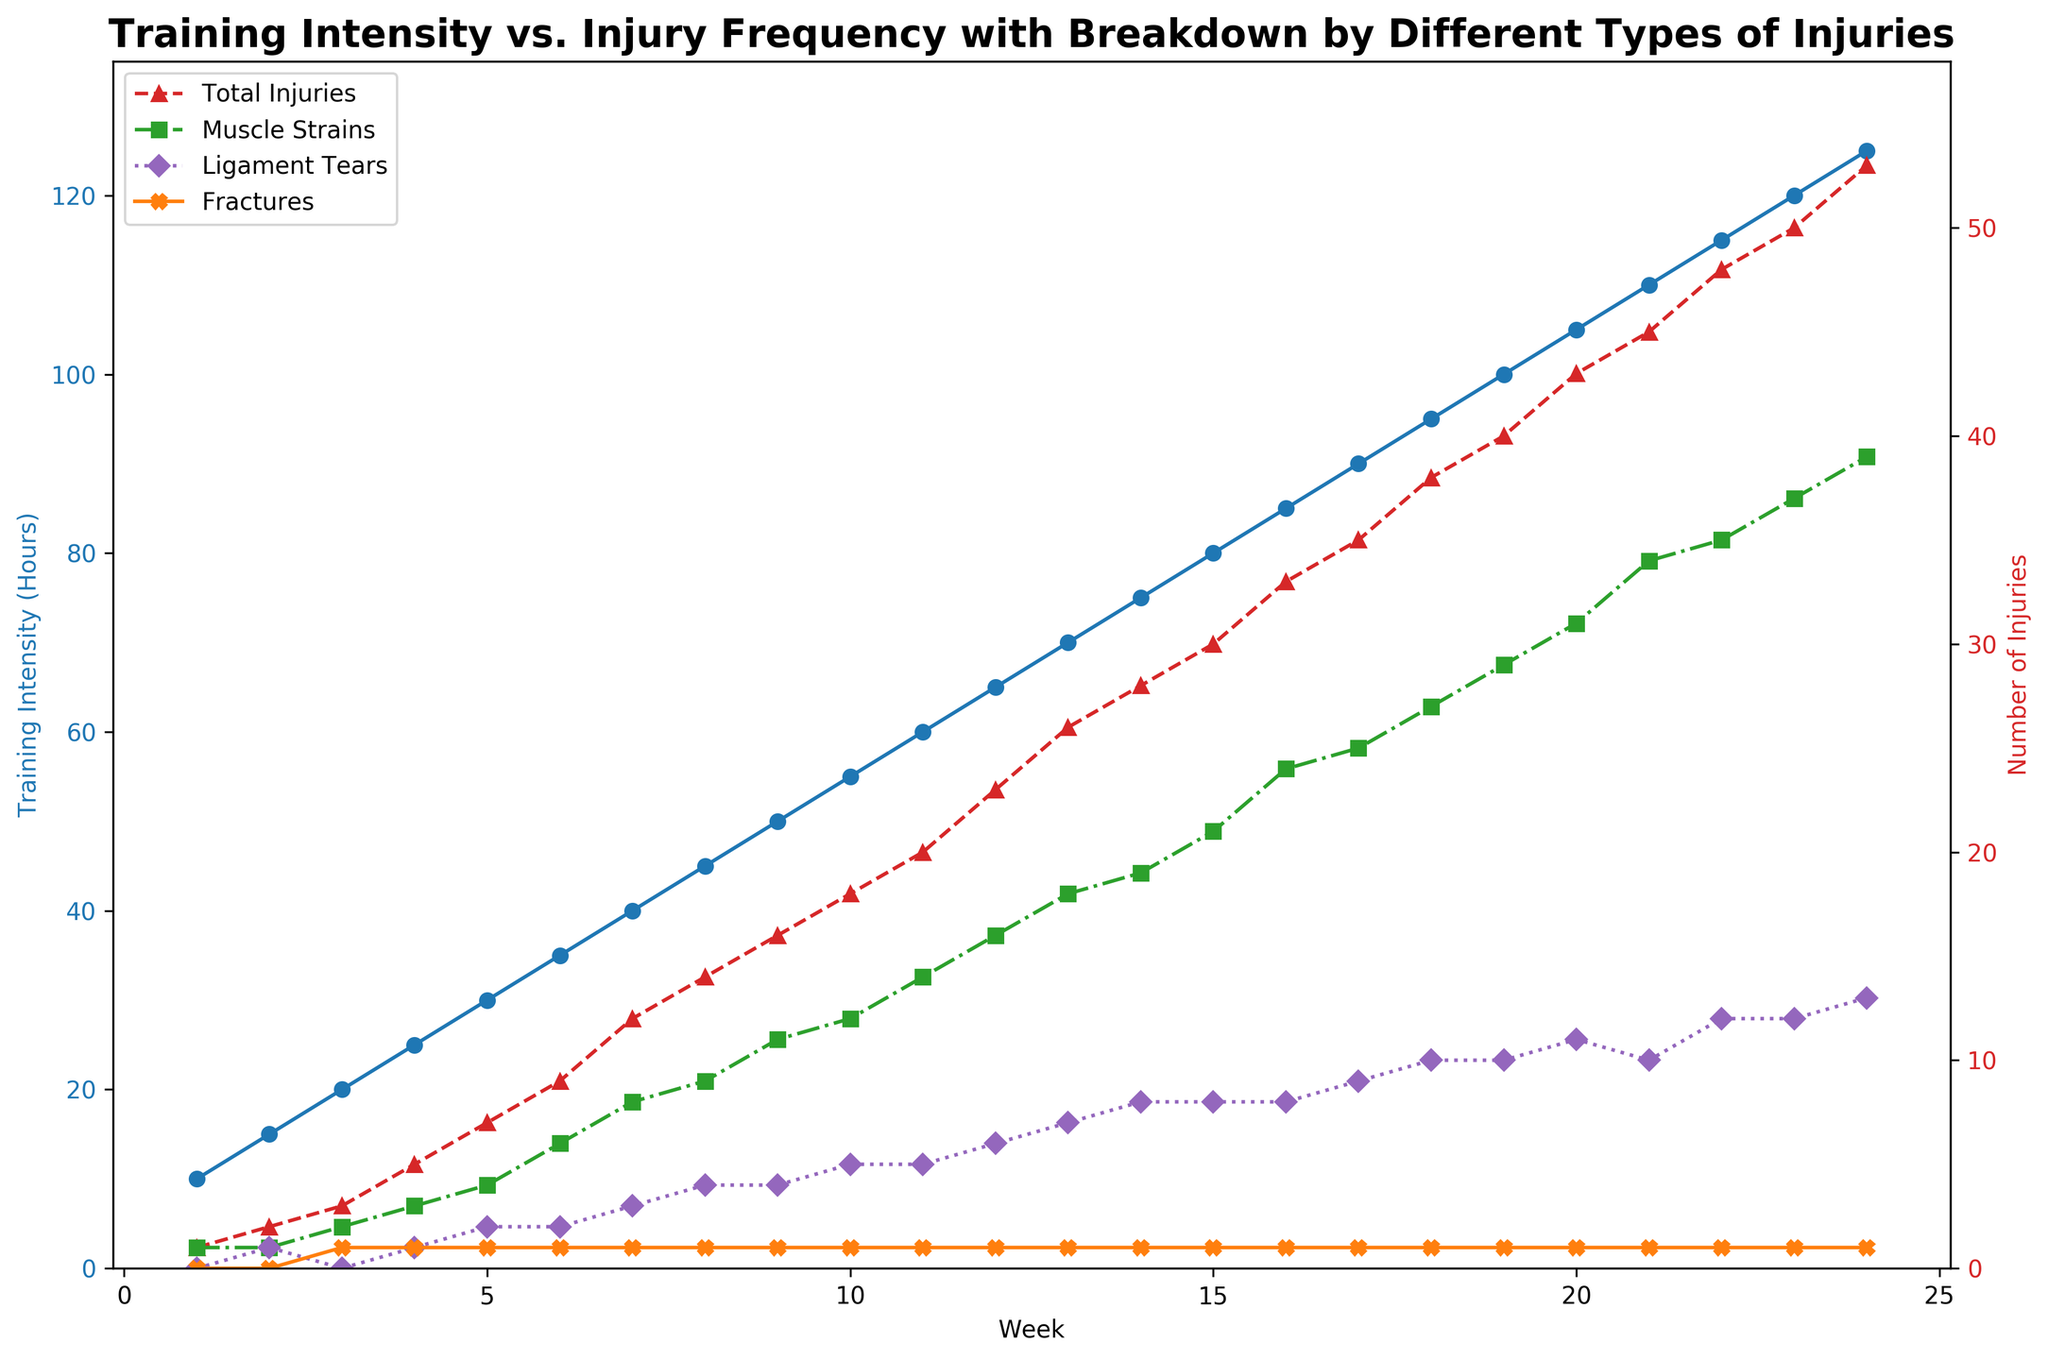How does the training intensity change from week 1 to week 24? To determine the change, compare the values at week 1 and week 24. At week 1, the training intensity is 10 hours. At week 24, it is 125 hours. The change is 125 - 10 = 115 hours.
Answer: 115 hours Which week has the highest number of muscle strains? Look for the maximum value in the muscle strains line plot and map it to the week. The maximum number of muscle strains is 39, which occurs in week 24.
Answer: Week 24 What is the general trend of total injuries as training intensity increases? Generally, observe the pattern in both total injuries and training intensity lines. As the training intensity increases, the total number of injuries also increases over time.
Answer: Increasing At which week do ligament tears first exceed 3? Identify where the ligament tears line crosses the number 3. By tracing the data, ligament tears first exceed 3 in week 7.
Answer: Week 7 Compare the number of fractures in week 5 and week 10. Check the number of fractures at weeks 5 and 10. Both weeks show 1 fracture.
Answer: Same What is the primary type of injury in week 16? Compare the breakdown of injuries in week 16. Muscle strains are the highest at 24, compared to 8 ligament tears and 1 fracture.
Answer: Muscle strains Calculate the average number of ligament tears over the 24 weeks. Sum the total number of ligament tears and divide by 24. Total ligament tears = 155 (sum up each week's count). Average = 155 / 24 ≈ 6.46
Answer: 6.46 From week 15 to week 20, what is the increase in total injuries? Compare total injuries at week 15 (30) to week 20 (43). The increase is 43 - 30 = 13.
Answer: 13 How many total injuries were recorded by week 12? Sum the total injuries from week 1 to week 12. The sum is 1 + 2 + 3 + 5 + 7 + 9 + 12 + 14 + 16 + 18 + 20 + 23 = 130.
Answer: 130 Compare the visual appearance of muscle strains and fractures lines. Observe the line plot styles. The muscle strains line is green with 's' markers, whereas the fractures line is orange with 'X' markers.
Answer: Muscle strains: green with square markers, Fractures: orange with X markers 